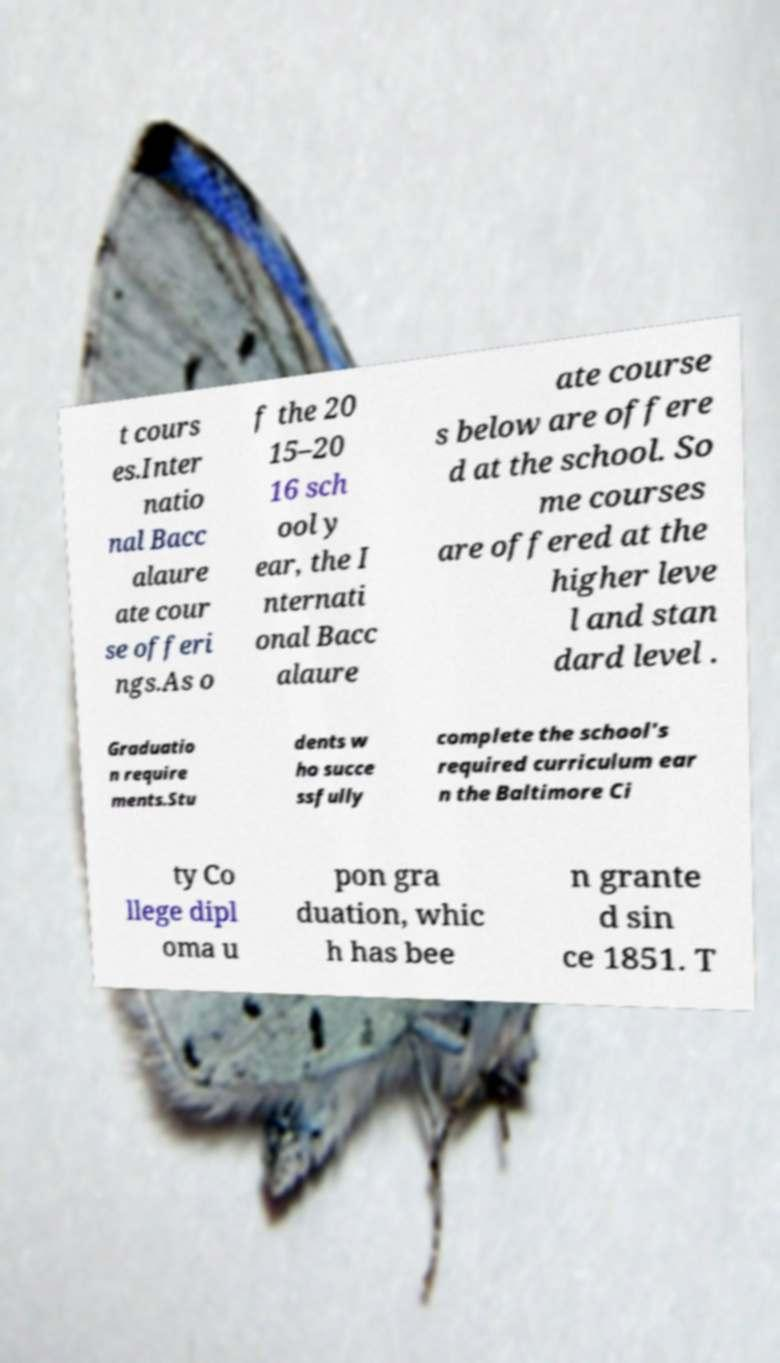There's text embedded in this image that I need extracted. Can you transcribe it verbatim? t cours es.Inter natio nal Bacc alaure ate cour se offeri ngs.As o f the 20 15–20 16 sch ool y ear, the I nternati onal Bacc alaure ate course s below are offere d at the school. So me courses are offered at the higher leve l and stan dard level . Graduatio n require ments.Stu dents w ho succe ssfully complete the school's required curriculum ear n the Baltimore Ci ty Co llege dipl oma u pon gra duation, whic h has bee n grante d sin ce 1851. T 